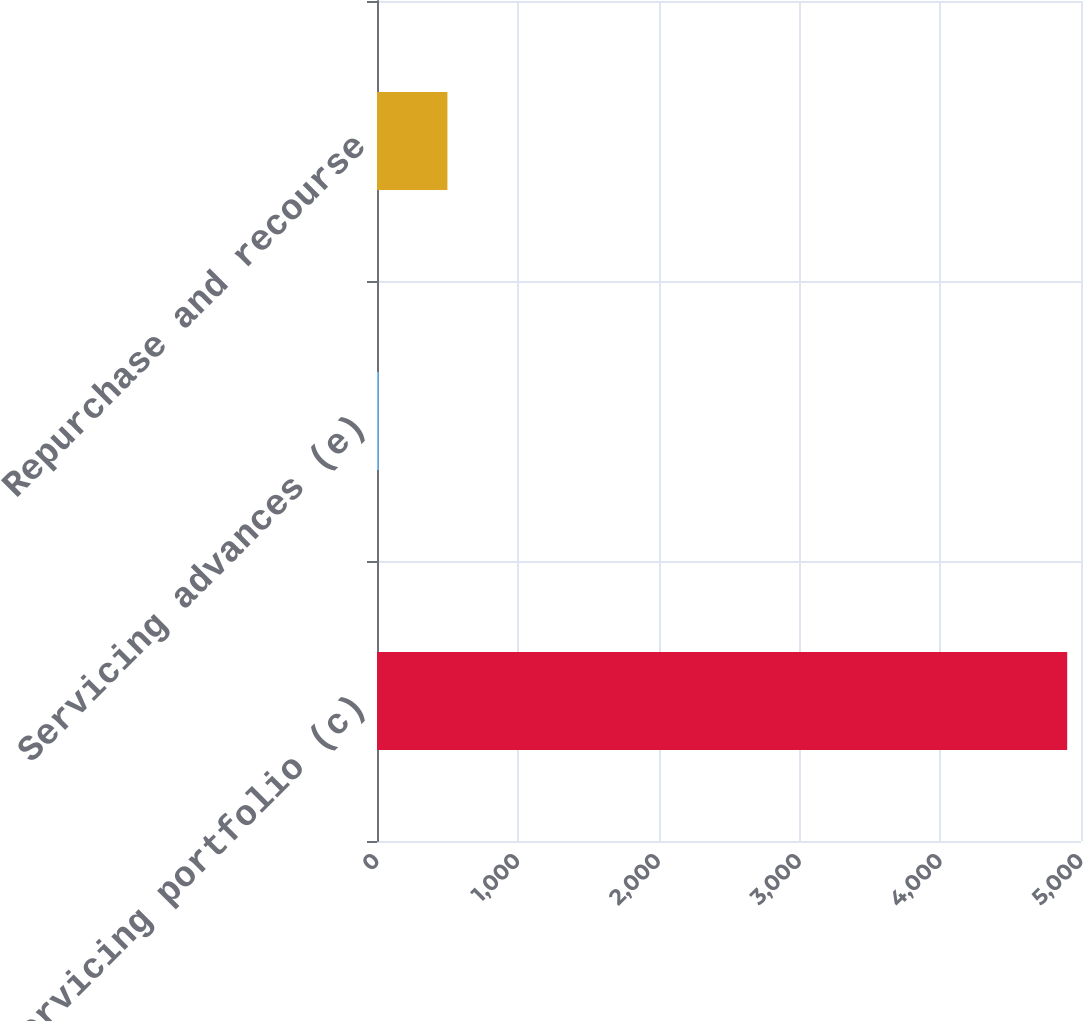<chart> <loc_0><loc_0><loc_500><loc_500><bar_chart><fcel>Servicing portfolio (c)<fcel>Servicing advances (e)<fcel>Repurchase and recourse<nl><fcel>4902<fcel>11<fcel>500.1<nl></chart> 